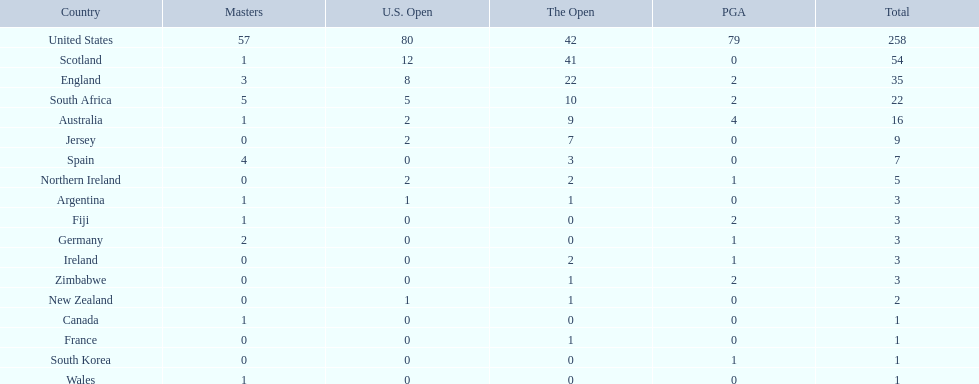Could you name all the countries in the world? United States, Scotland, England, South Africa, Australia, Jersey, Spain, Northern Ireland, Argentina, Fiji, Germany, Ireland, Zimbabwe, New Zealand, Canada, France, South Korea, Wales. Which of these are in africa? South Africa, Zimbabwe. Among the african countries, which one has the lowest number of successful golfers? Zimbabwe. 